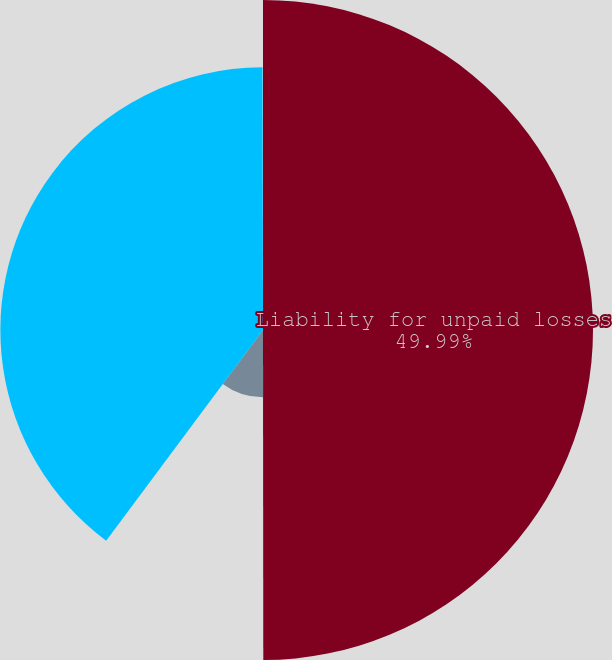Convert chart to OTSL. <chart><loc_0><loc_0><loc_500><loc_500><pie_chart><fcel>Liability for unpaid losses<fcel>Less amount of discount<fcel>Carrying value of liability<fcel>Weighted average discount rate<nl><fcel>49.98%<fcel>10.2%<fcel>39.78%<fcel>0.03%<nl></chart> 